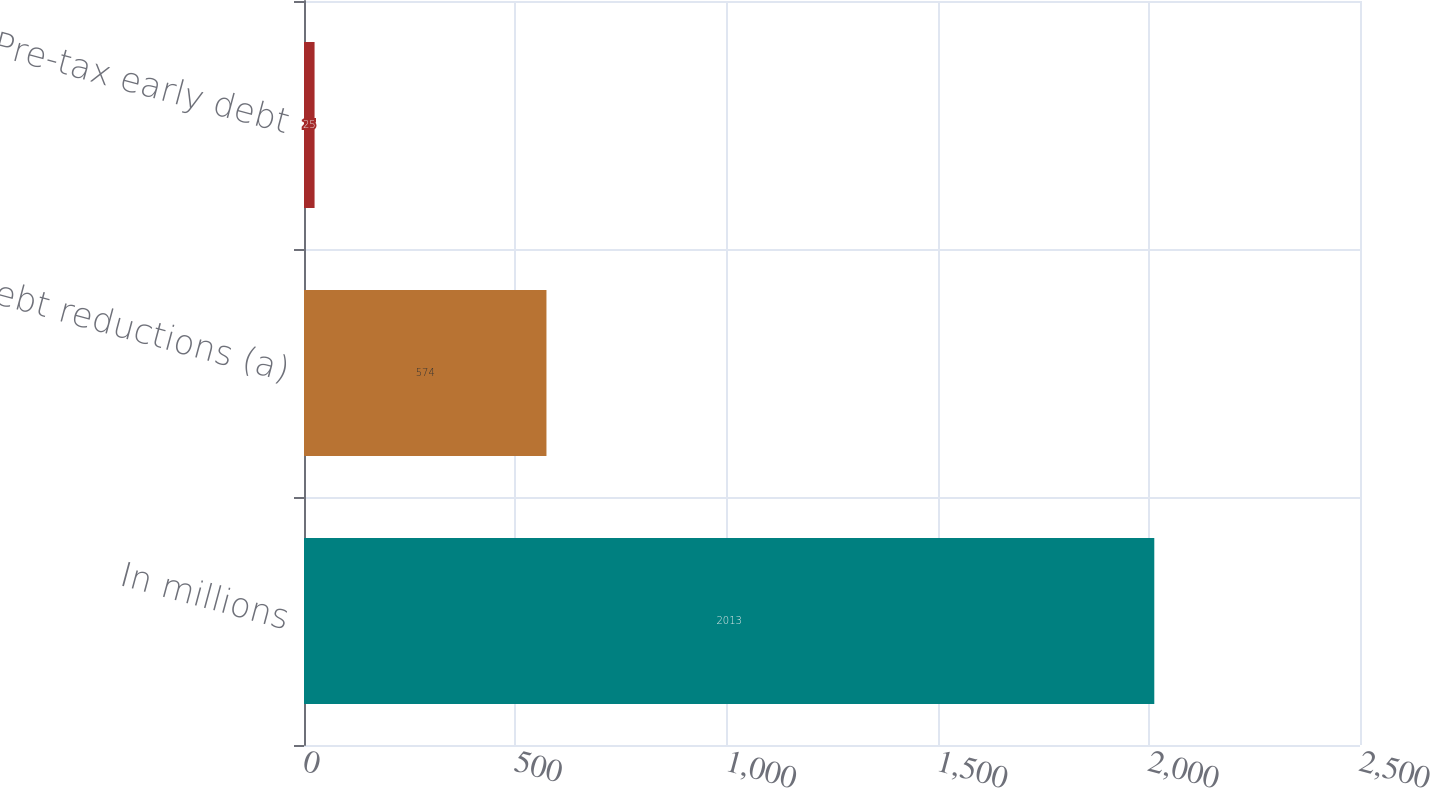<chart> <loc_0><loc_0><loc_500><loc_500><bar_chart><fcel>In millions<fcel>Debt reductions (a)<fcel>Pre-tax early debt<nl><fcel>2013<fcel>574<fcel>25<nl></chart> 